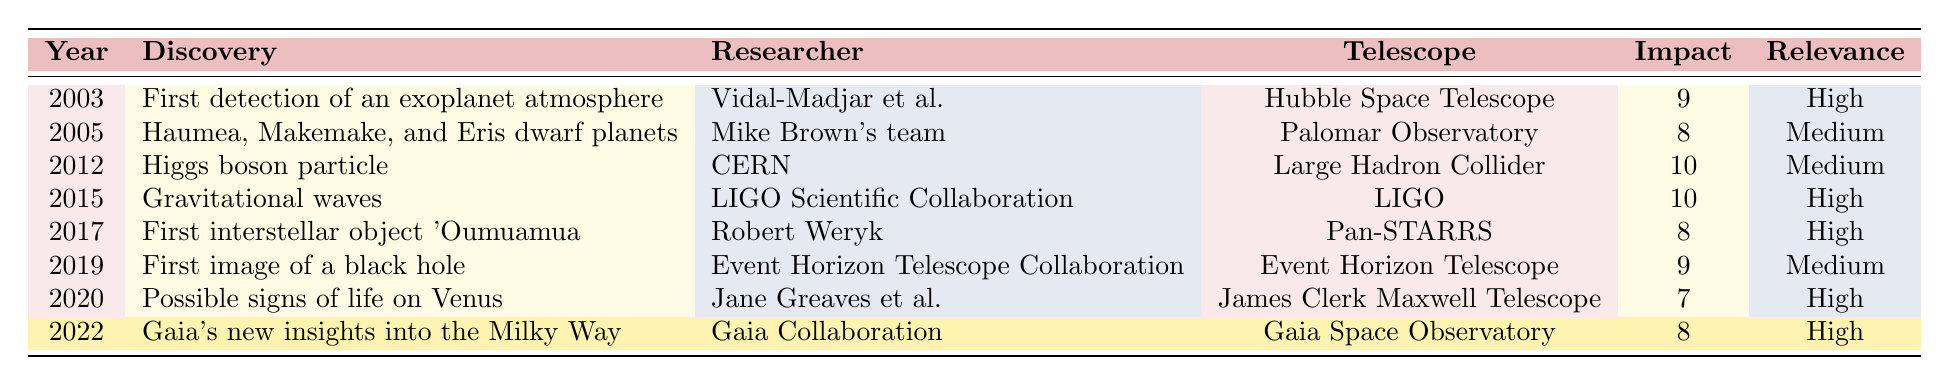What scientific discovery occurred in 2015? According to the table, in 2015, the discovery made was gravitational waves.
Answer: Gravitational waves Which telescope was used to detect the first exoplanet atmosphere? The table states that the Hubble Space Telescope was used for the first detection of an exoplanet atmosphere in 2003.
Answer: Hubble Space Telescope How many discoveries have a high relevance to space exploration? There are five entries in the table where the relevance to space exploration is rated as high (2003, 2015, 2017, 2020, and 2022).
Answer: Five What was the impact score of the Higgs boson particle discovery? The table shows that the impact score for the Higgs boson particle discovery in 2012 was 10.
Answer: 10 Did any of the discoveries have a Peruvian contribution? The table indicates that only the discovery in 2022 by the Gaia Collaboration has a Peruvian contribution, as marked with true.
Answer: Yes What is the average impact score of the discoveries listed? The impact scores are 9, 8, 10, 10, 8, 9, 7, and 8. The sum is 69, and since there are 8 discoveries, the average is 69/8 = 8.625.
Answer: 8.625 Which discovery by the Gaia Collaboration occurred most recently? The most recent discovery by Gaia Collaboration occurred in 2022, according to the table.
Answer: 2022 What percentage of discoveries listed have a relevance to space exploration rated as medium? The table shows 3 discoveries with medium relevance out of 8 total, which is (3/8) * 100 = 37.5%.
Answer: 37.5% How does the impact score of the first interstellar object compare to the gravitational waves discovery? The impact score for the first interstellar object 'Oumuamua is 8, while gravitational waves' impact score is 10, indicating that gravitational waves had a higher score.
Answer: Higher Can you identify any discoveries made using the LIGO telescope? The table specifies that gravitational waves were detected using the LIGO telescope in 2015.
Answer: Gravitational waves 